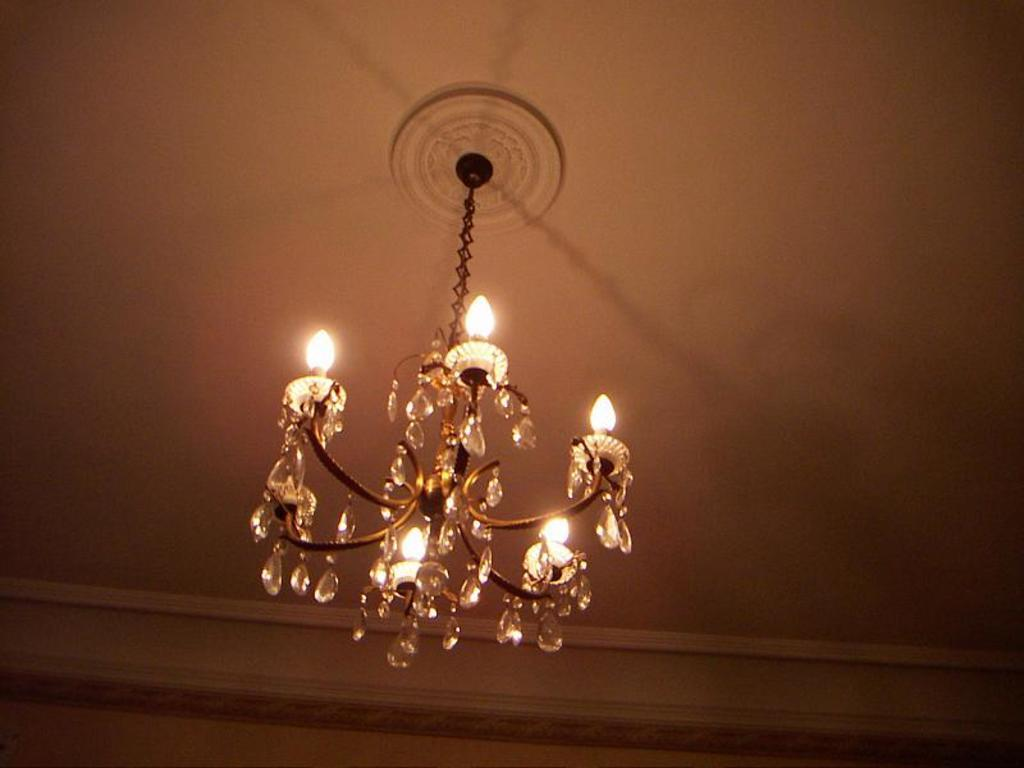What type of lighting fixture is present in the image? There is a chandelier in the image. Where is the chandelier located in relation to the roof? The chandelier is hanging from the roof. What material appears to be used for the chain holding the chandelier? The chain holding the chandelier appears to be made of iron. What type of winter sport is being played in the image? There is no winter sport or any indication of winter in the image; it features a chandelier hanging from the roof. What type of copper alloy is used for the chandelier in the image? The image does not mention or show any copper alloy being used for the chandelier; it only states that the chain appears to be made of iron. 